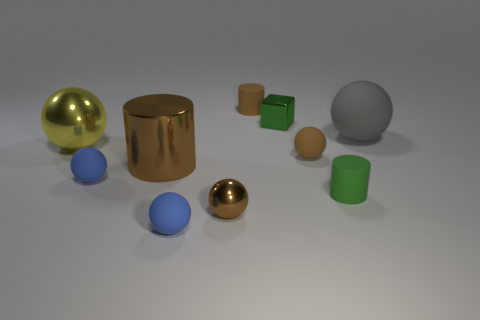There is a small object that is to the right of the tiny brown rubber cylinder and behind the large yellow metallic ball; what shape is it?
Provide a succinct answer. Cube. There is a metal block; is it the same size as the ball on the right side of the tiny brown matte sphere?
Give a very brief answer. No. What color is the other large shiny thing that is the same shape as the gray thing?
Offer a terse response. Yellow. There is a brown ball behind the tiny green rubber object; is its size the same as the rubber cylinder that is in front of the yellow ball?
Your response must be concise. Yes. Does the big gray matte thing have the same shape as the yellow object?
Keep it short and to the point. Yes. How many objects are either brown matte things in front of the yellow ball or small cylinders?
Your answer should be very brief. 3. Is there a tiny matte thing of the same shape as the tiny green metallic thing?
Ensure brevity in your answer.  No. Are there an equal number of large gray objects that are left of the large matte object and tiny yellow blocks?
Provide a succinct answer. Yes. What shape is the tiny rubber thing that is the same color as the tiny metal block?
Give a very brief answer. Cylinder. What number of brown matte things have the same size as the yellow ball?
Your answer should be very brief. 0. 